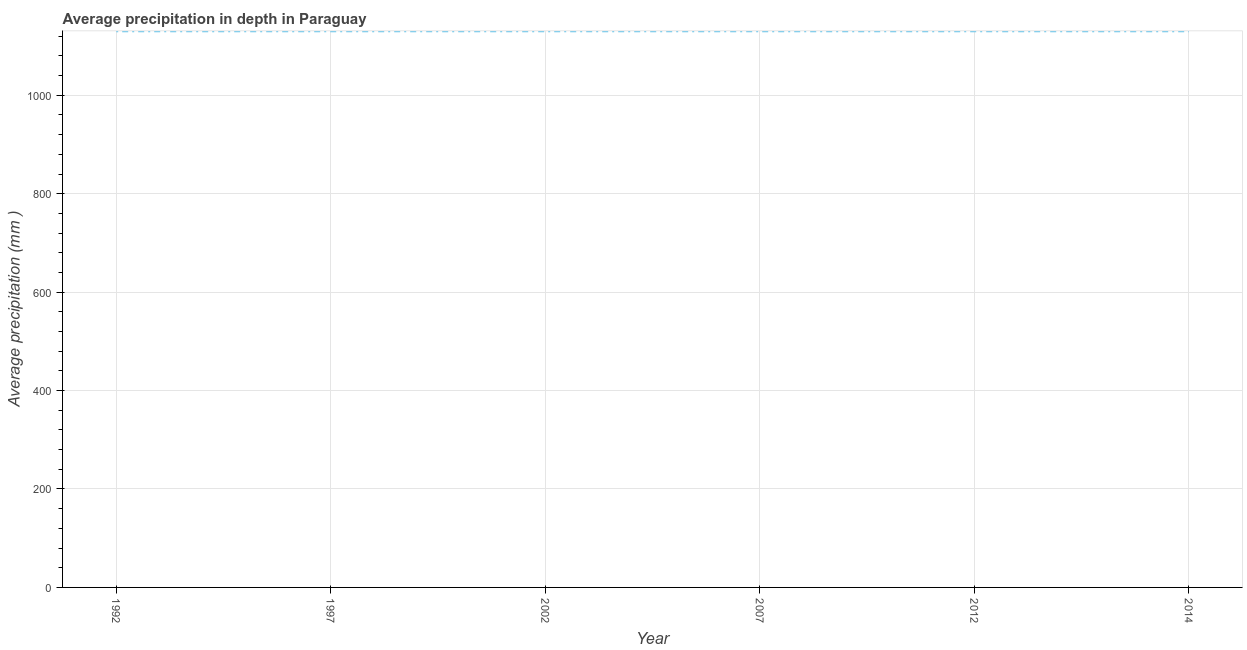What is the average precipitation in depth in 2007?
Keep it short and to the point. 1130. Across all years, what is the maximum average precipitation in depth?
Keep it short and to the point. 1130. Across all years, what is the minimum average precipitation in depth?
Keep it short and to the point. 1130. In which year was the average precipitation in depth maximum?
Offer a very short reply. 1992. In which year was the average precipitation in depth minimum?
Provide a succinct answer. 1992. What is the sum of the average precipitation in depth?
Offer a terse response. 6780. What is the average average precipitation in depth per year?
Offer a terse response. 1130. What is the median average precipitation in depth?
Offer a very short reply. 1130. In how many years, is the average precipitation in depth greater than 440 mm?
Your response must be concise. 6. What is the ratio of the average precipitation in depth in 1997 to that in 2014?
Keep it short and to the point. 1. Is the average precipitation in depth in 2002 less than that in 2012?
Provide a short and direct response. No. Is the difference between the average precipitation in depth in 1992 and 2002 greater than the difference between any two years?
Keep it short and to the point. Yes. What is the difference between the highest and the second highest average precipitation in depth?
Your answer should be very brief. 0. Is the sum of the average precipitation in depth in 1997 and 2012 greater than the maximum average precipitation in depth across all years?
Make the answer very short. Yes. How many years are there in the graph?
Your answer should be compact. 6. What is the difference between two consecutive major ticks on the Y-axis?
Give a very brief answer. 200. Does the graph contain any zero values?
Your answer should be very brief. No. What is the title of the graph?
Make the answer very short. Average precipitation in depth in Paraguay. What is the label or title of the Y-axis?
Your answer should be compact. Average precipitation (mm ). What is the Average precipitation (mm ) of 1992?
Provide a short and direct response. 1130. What is the Average precipitation (mm ) of 1997?
Keep it short and to the point. 1130. What is the Average precipitation (mm ) of 2002?
Your answer should be compact. 1130. What is the Average precipitation (mm ) of 2007?
Make the answer very short. 1130. What is the Average precipitation (mm ) of 2012?
Ensure brevity in your answer.  1130. What is the Average precipitation (mm ) in 2014?
Your response must be concise. 1130. What is the difference between the Average precipitation (mm ) in 1992 and 2012?
Your answer should be compact. 0. What is the difference between the Average precipitation (mm ) in 1997 and 2012?
Your answer should be compact. 0. What is the difference between the Average precipitation (mm ) in 2002 and 2007?
Make the answer very short. 0. What is the difference between the Average precipitation (mm ) in 2002 and 2012?
Your response must be concise. 0. What is the difference between the Average precipitation (mm ) in 2002 and 2014?
Make the answer very short. 0. What is the difference between the Average precipitation (mm ) in 2007 and 2012?
Provide a short and direct response. 0. What is the difference between the Average precipitation (mm ) in 2012 and 2014?
Offer a terse response. 0. What is the ratio of the Average precipitation (mm ) in 1992 to that in 1997?
Ensure brevity in your answer.  1. What is the ratio of the Average precipitation (mm ) in 1992 to that in 2002?
Offer a very short reply. 1. What is the ratio of the Average precipitation (mm ) in 1992 to that in 2012?
Offer a very short reply. 1. What is the ratio of the Average precipitation (mm ) in 1992 to that in 2014?
Offer a very short reply. 1. What is the ratio of the Average precipitation (mm ) in 1997 to that in 2002?
Offer a terse response. 1. What is the ratio of the Average precipitation (mm ) in 1997 to that in 2014?
Offer a very short reply. 1. What is the ratio of the Average precipitation (mm ) in 2002 to that in 2012?
Provide a succinct answer. 1. What is the ratio of the Average precipitation (mm ) in 2002 to that in 2014?
Offer a terse response. 1. What is the ratio of the Average precipitation (mm ) in 2012 to that in 2014?
Keep it short and to the point. 1. 